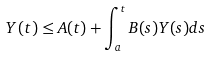<formula> <loc_0><loc_0><loc_500><loc_500>Y ( t ) \leq A ( t ) + \int _ { a } ^ { t } B ( s ) Y ( s ) d s</formula> 